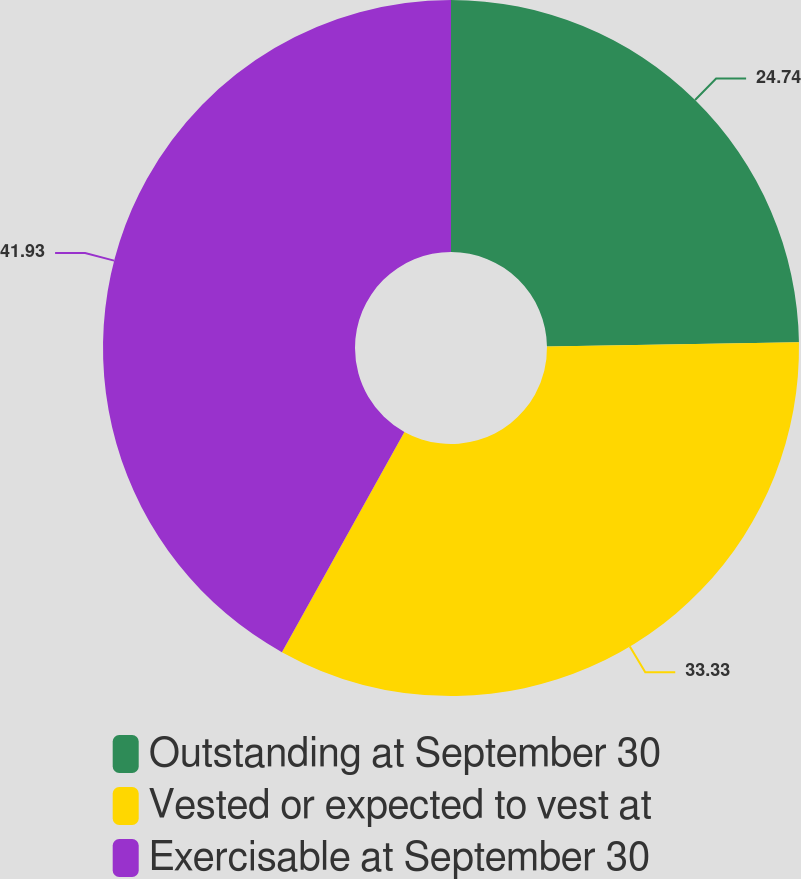Convert chart to OTSL. <chart><loc_0><loc_0><loc_500><loc_500><pie_chart><fcel>Outstanding at September 30<fcel>Vested or expected to vest at<fcel>Exercisable at September 30<nl><fcel>24.74%<fcel>33.33%<fcel>41.92%<nl></chart> 